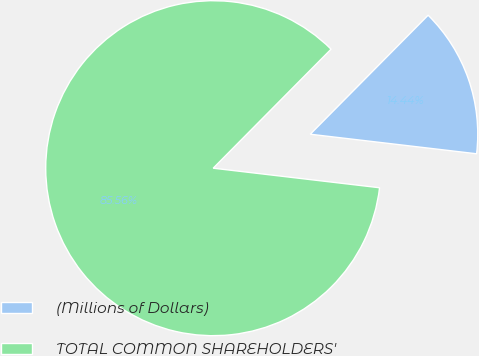Convert chart. <chart><loc_0><loc_0><loc_500><loc_500><pie_chart><fcel>(Millions of Dollars)<fcel>TOTAL COMMON SHAREHOLDERS'<nl><fcel>14.44%<fcel>85.56%<nl></chart> 